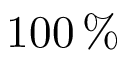Convert formula to latex. <formula><loc_0><loc_0><loc_500><loc_500>1 0 0 \, \%</formula> 